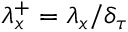Convert formula to latex. <formula><loc_0><loc_0><loc_500><loc_500>\lambda _ { x } ^ { + } = \lambda _ { x } / \delta _ { \tau }</formula> 